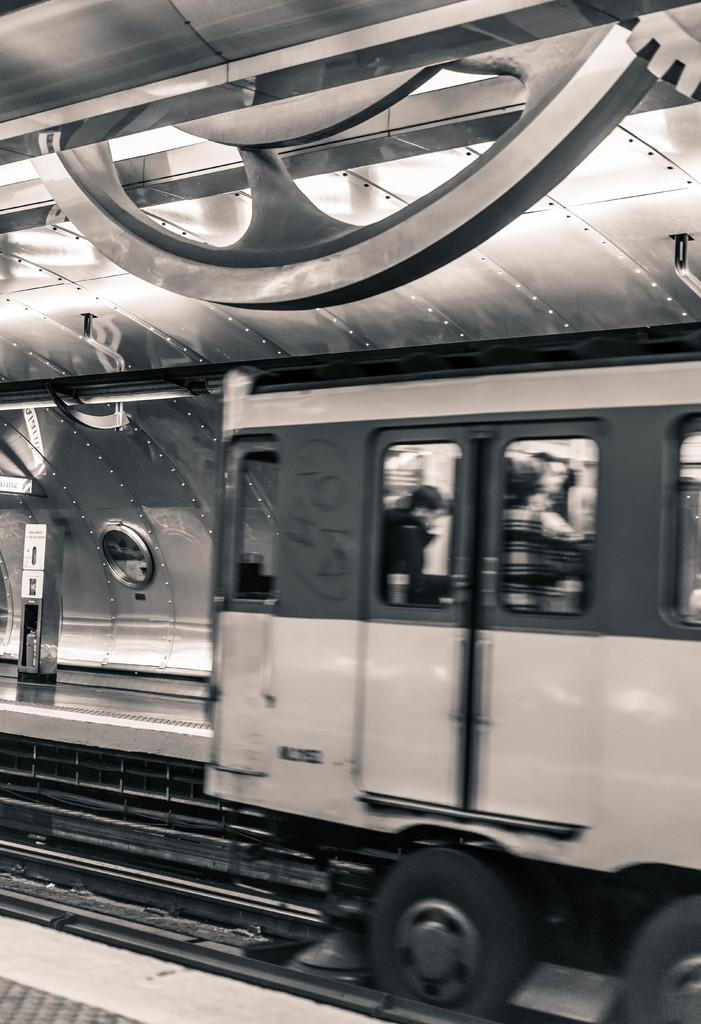What mode of transportation are the people in the image using? The people are in a train. Where is the train located? The train is on a railway track. What can be seen near the train? There is a platform visible in the image. What type of structure is present in the image? There is a shed in the image. Can you describe any objects present in the image? There are objects present in the image, but their specific details are not mentioned in the provided facts. What color is the owner's paint on the train? There is no information about the train's owner or the color of any paint in the image. 